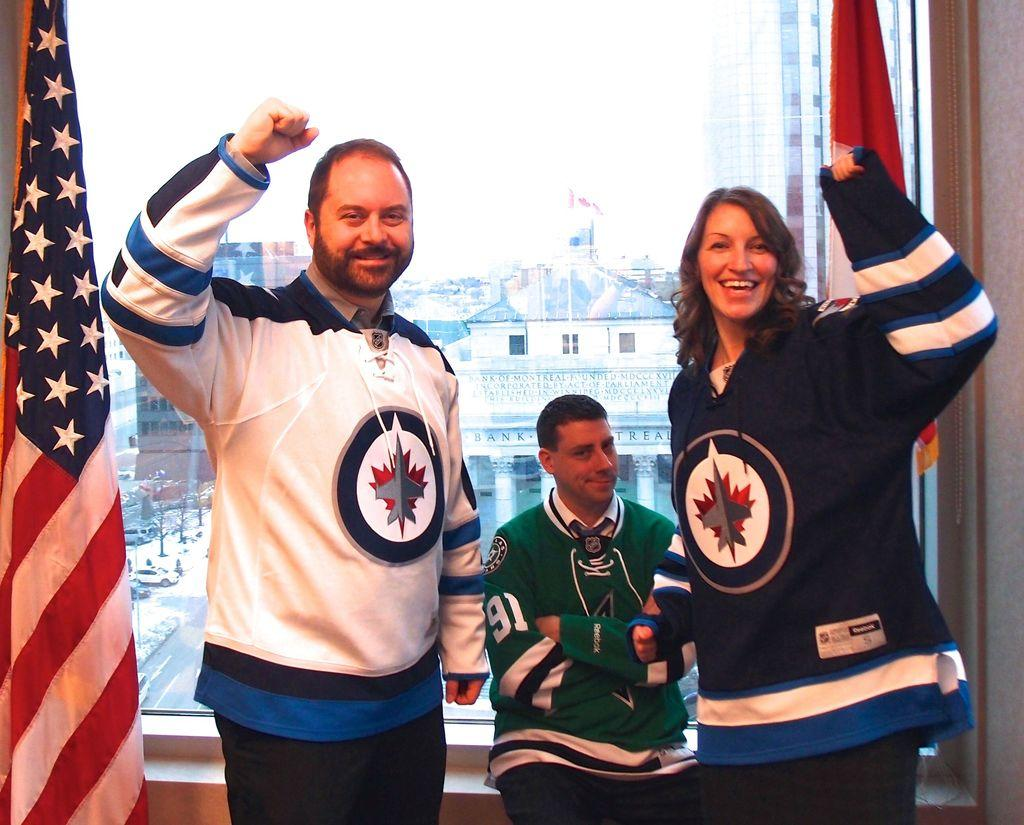Provide a one-sentence caption for the provided image. A tiny man wearing a Reebok jersey sits between two celebrating people. 